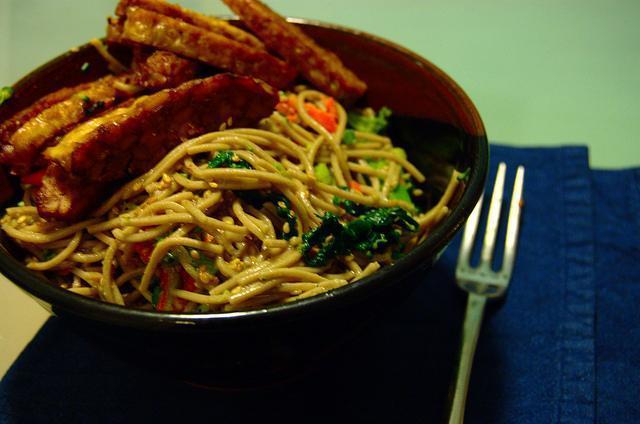Is the caption "The bowl contains the hot dog." a true representation of the image?
Answer yes or no. Yes. 